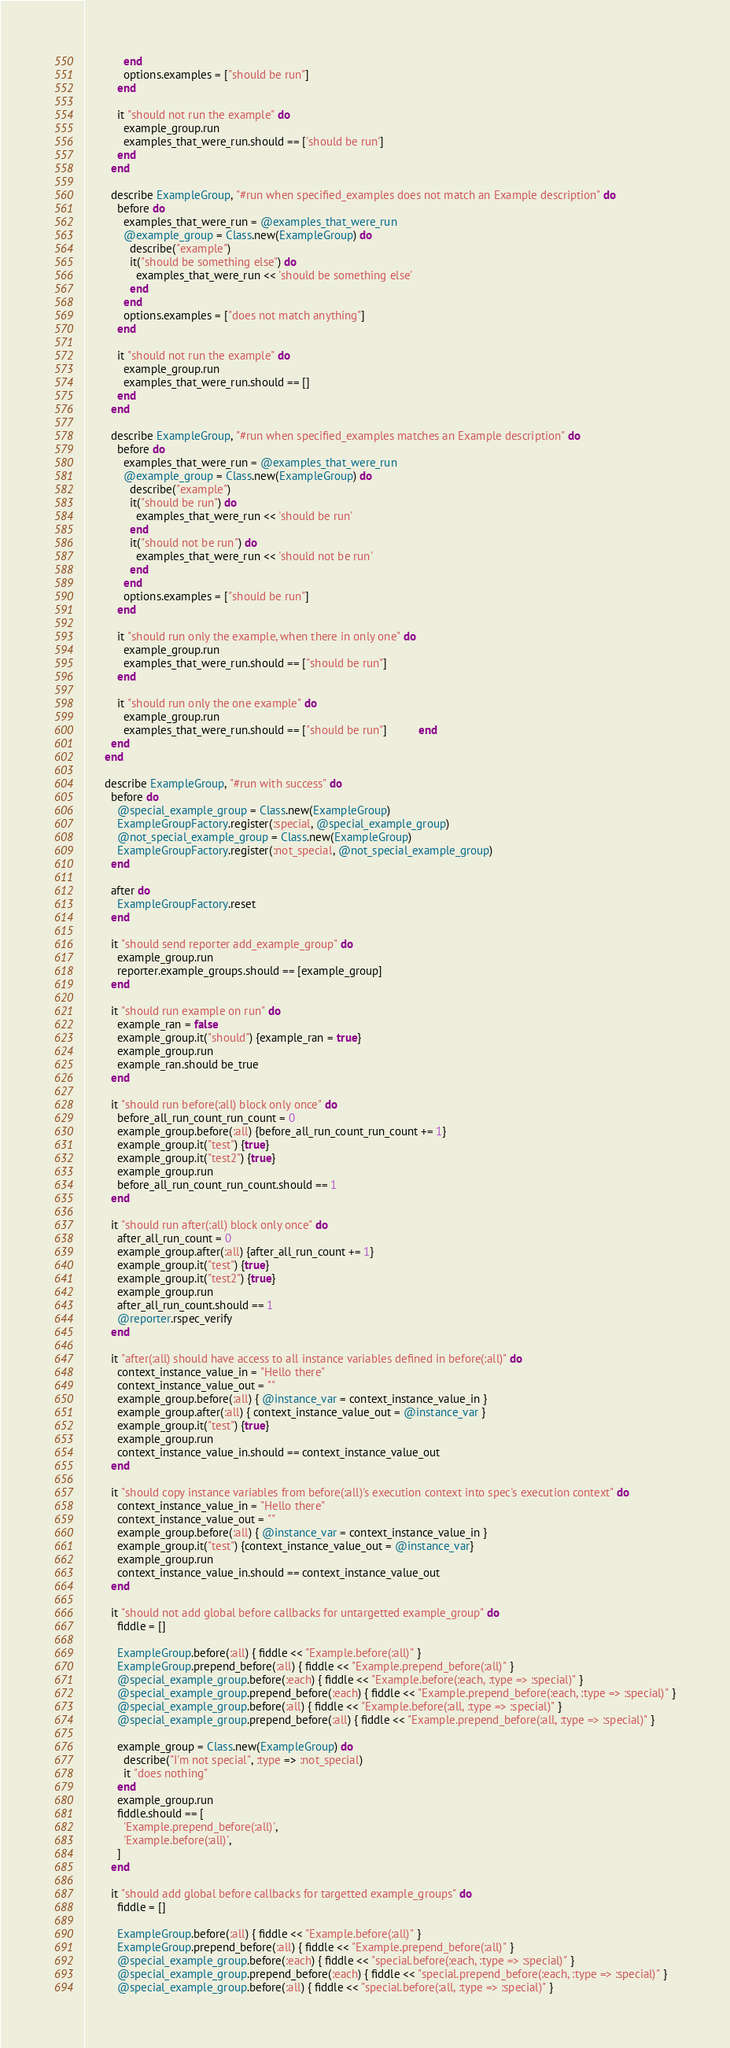<code> <loc_0><loc_0><loc_500><loc_500><_Ruby_>            end
            options.examples = ["should be run"]
          end

          it "should not run the example" do
            example_group.run
            examples_that_were_run.should == ['should be run']
          end
        end

        describe ExampleGroup, "#run when specified_examples does not match an Example description" do
          before do
            examples_that_were_run = @examples_that_were_run
            @example_group = Class.new(ExampleGroup) do
              describe("example")
              it("should be something else") do
                examples_that_were_run << 'should be something else'
              end
            end
            options.examples = ["does not match anything"]
          end

          it "should not run the example" do
            example_group.run
            examples_that_were_run.should == []
          end
        end

        describe ExampleGroup, "#run when specified_examples matches an Example description" do
          before do
            examples_that_were_run = @examples_that_were_run
            @example_group = Class.new(ExampleGroup) do
              describe("example")
              it("should be run") do
                examples_that_were_run << 'should be run'
              end
              it("should not be run") do
                examples_that_were_run << 'should not be run'
              end
            end
            options.examples = ["should be run"]
          end

          it "should run only the example, when there in only one" do
            example_group.run
            examples_that_were_run.should == ["should be run"]
          end

          it "should run only the one example" do
            example_group.run
            examples_that_were_run.should == ["should be run"]          end
        end
      end

      describe ExampleGroup, "#run with success" do
        before do
          @special_example_group = Class.new(ExampleGroup)
          ExampleGroupFactory.register(:special, @special_example_group)
          @not_special_example_group = Class.new(ExampleGroup)
          ExampleGroupFactory.register(:not_special, @not_special_example_group)
        end

        after do
          ExampleGroupFactory.reset
        end

        it "should send reporter add_example_group" do
          example_group.run
          reporter.example_groups.should == [example_group]
        end

        it "should run example on run" do
          example_ran = false
          example_group.it("should") {example_ran = true}
          example_group.run
          example_ran.should be_true
        end

        it "should run before(:all) block only once" do
          before_all_run_count_run_count = 0
          example_group.before(:all) {before_all_run_count_run_count += 1}
          example_group.it("test") {true}
          example_group.it("test2") {true}
          example_group.run
          before_all_run_count_run_count.should == 1
        end

        it "should run after(:all) block only once" do
          after_all_run_count = 0
          example_group.after(:all) {after_all_run_count += 1}
          example_group.it("test") {true}
          example_group.it("test2") {true}
          example_group.run
          after_all_run_count.should == 1
          @reporter.rspec_verify
        end

        it "after(:all) should have access to all instance variables defined in before(:all)" do
          context_instance_value_in = "Hello there"
          context_instance_value_out = ""
          example_group.before(:all) { @instance_var = context_instance_value_in }
          example_group.after(:all) { context_instance_value_out = @instance_var }
          example_group.it("test") {true}
          example_group.run
          context_instance_value_in.should == context_instance_value_out
        end

        it "should copy instance variables from before(:all)'s execution context into spec's execution context" do
          context_instance_value_in = "Hello there"
          context_instance_value_out = ""
          example_group.before(:all) { @instance_var = context_instance_value_in }
          example_group.it("test") {context_instance_value_out = @instance_var}
          example_group.run
          context_instance_value_in.should == context_instance_value_out
        end

        it "should not add global before callbacks for untargetted example_group" do
          fiddle = []

          ExampleGroup.before(:all) { fiddle << "Example.before(:all)" }
          ExampleGroup.prepend_before(:all) { fiddle << "Example.prepend_before(:all)" }
          @special_example_group.before(:each) { fiddle << "Example.before(:each, :type => :special)" }
          @special_example_group.prepend_before(:each) { fiddle << "Example.prepend_before(:each, :type => :special)" }
          @special_example_group.before(:all) { fiddle << "Example.before(:all, :type => :special)" }
          @special_example_group.prepend_before(:all) { fiddle << "Example.prepend_before(:all, :type => :special)" }

          example_group = Class.new(ExampleGroup) do
            describe("I'm not special", :type => :not_special)
            it "does nothing"
          end
          example_group.run
          fiddle.should == [
            'Example.prepend_before(:all)',
            'Example.before(:all)',
          ]
        end

        it "should add global before callbacks for targetted example_groups" do
          fiddle = []

          ExampleGroup.before(:all) { fiddle << "Example.before(:all)" }
          ExampleGroup.prepend_before(:all) { fiddle << "Example.prepend_before(:all)" }
          @special_example_group.before(:each) { fiddle << "special.before(:each, :type => :special)" }
          @special_example_group.prepend_before(:each) { fiddle << "special.prepend_before(:each, :type => :special)" }
          @special_example_group.before(:all) { fiddle << "special.before(:all, :type => :special)" }</code> 